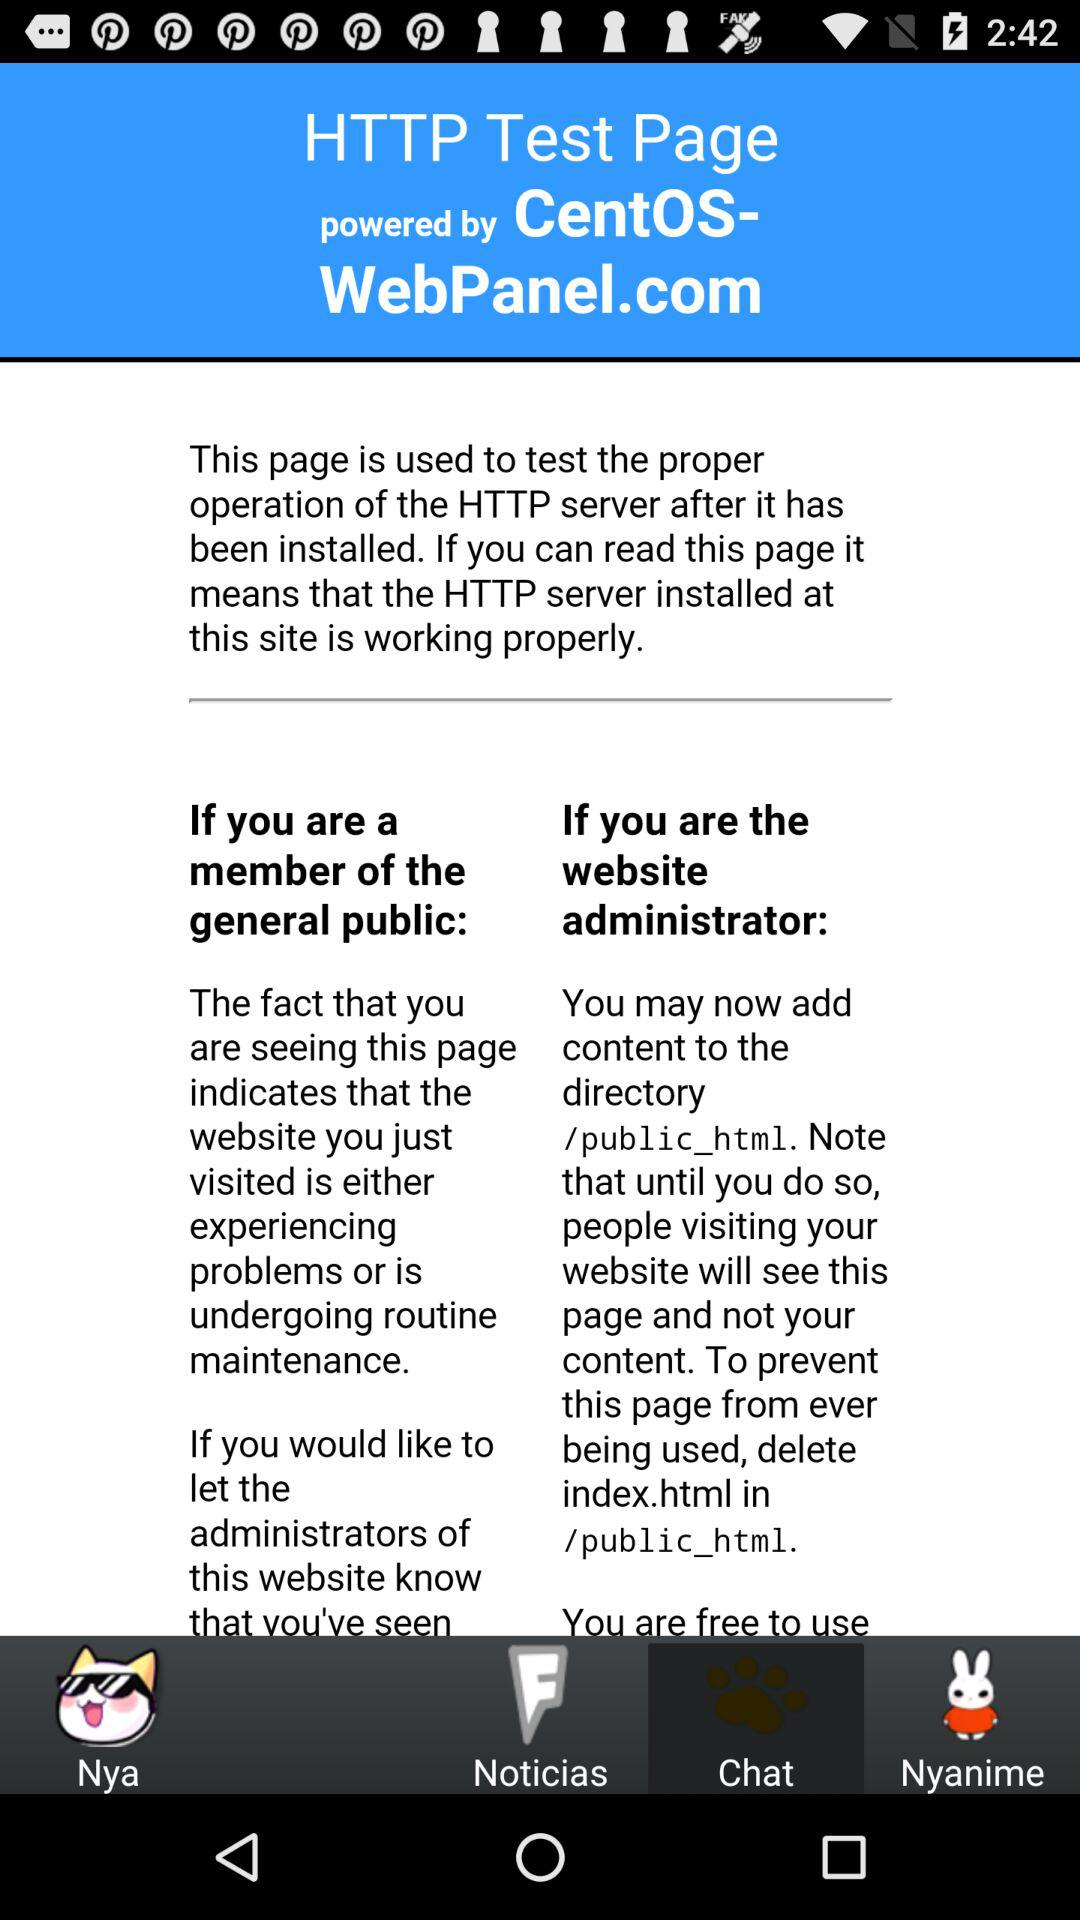Which tab has been selected? The tab "Chat" has been selected. 